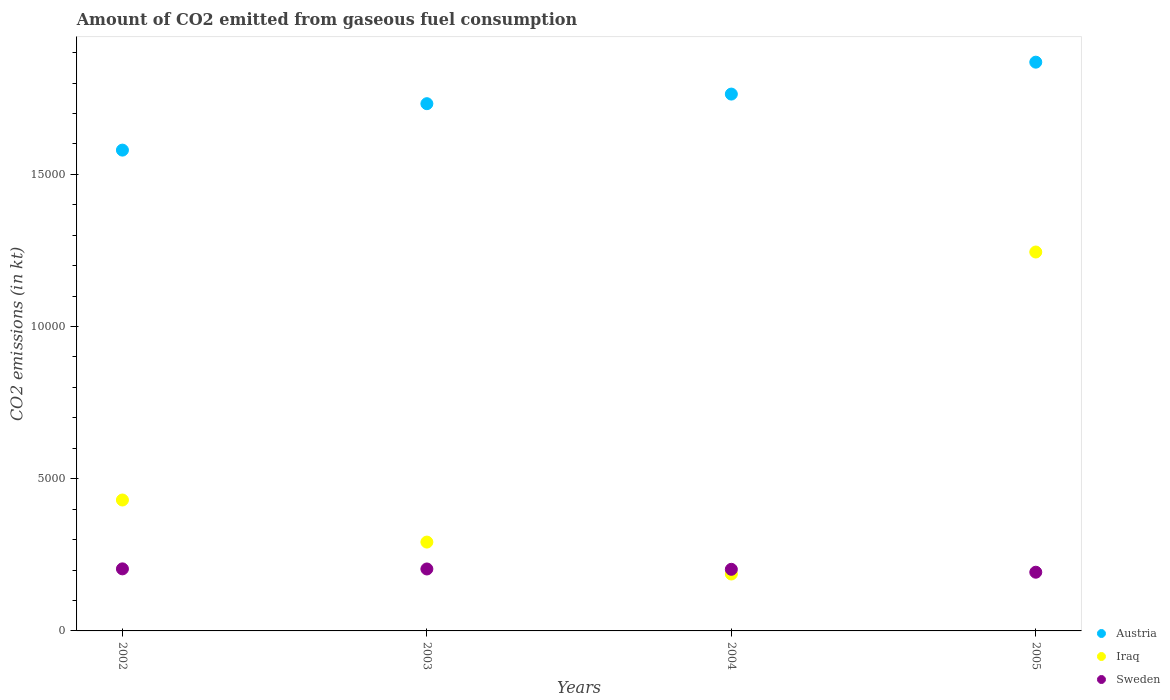How many different coloured dotlines are there?
Your response must be concise. 3. What is the amount of CO2 emitted in Iraq in 2004?
Keep it short and to the point. 1870.17. Across all years, what is the maximum amount of CO2 emitted in Sweden?
Keep it short and to the point. 2038.85. Across all years, what is the minimum amount of CO2 emitted in Austria?
Keep it short and to the point. 1.58e+04. What is the total amount of CO2 emitted in Austria in the graph?
Give a very brief answer. 6.94e+04. What is the difference between the amount of CO2 emitted in Austria in 2002 and that in 2004?
Give a very brief answer. -1840.83. What is the difference between the amount of CO2 emitted in Iraq in 2004 and the amount of CO2 emitted in Sweden in 2002?
Give a very brief answer. -168.68. What is the average amount of CO2 emitted in Iraq per year?
Your answer should be compact. 5384.99. In the year 2004, what is the difference between the amount of CO2 emitted in Sweden and amount of CO2 emitted in Austria?
Your answer should be compact. -1.56e+04. What is the ratio of the amount of CO2 emitted in Sweden in 2002 to that in 2005?
Offer a terse response. 1.06. Is the amount of CO2 emitted in Sweden in 2002 less than that in 2005?
Provide a succinct answer. No. Is the difference between the amount of CO2 emitted in Sweden in 2003 and 2005 greater than the difference between the amount of CO2 emitted in Austria in 2003 and 2005?
Your answer should be compact. Yes. What is the difference between the highest and the second highest amount of CO2 emitted in Austria?
Make the answer very short. 1048.76. What is the difference between the highest and the lowest amount of CO2 emitted in Austria?
Give a very brief answer. 2889.6. Is it the case that in every year, the sum of the amount of CO2 emitted in Sweden and amount of CO2 emitted in Austria  is greater than the amount of CO2 emitted in Iraq?
Keep it short and to the point. Yes. Does the amount of CO2 emitted in Sweden monotonically increase over the years?
Make the answer very short. No. Is the amount of CO2 emitted in Austria strictly greater than the amount of CO2 emitted in Iraq over the years?
Ensure brevity in your answer.  Yes. Is the amount of CO2 emitted in Iraq strictly less than the amount of CO2 emitted in Austria over the years?
Your response must be concise. Yes. How many dotlines are there?
Ensure brevity in your answer.  3. How many years are there in the graph?
Your answer should be compact. 4. What is the difference between two consecutive major ticks on the Y-axis?
Provide a succinct answer. 5000. Are the values on the major ticks of Y-axis written in scientific E-notation?
Your answer should be very brief. No. Does the graph contain any zero values?
Offer a very short reply. No. Does the graph contain grids?
Give a very brief answer. No. Where does the legend appear in the graph?
Ensure brevity in your answer.  Bottom right. How many legend labels are there?
Ensure brevity in your answer.  3. How are the legend labels stacked?
Make the answer very short. Vertical. What is the title of the graph?
Ensure brevity in your answer.  Amount of CO2 emitted from gaseous fuel consumption. What is the label or title of the Y-axis?
Ensure brevity in your answer.  CO2 emissions (in kt). What is the CO2 emissions (in kt) of Austria in 2002?
Your answer should be compact. 1.58e+04. What is the CO2 emissions (in kt) in Iraq in 2002?
Ensure brevity in your answer.  4301.39. What is the CO2 emissions (in kt) of Sweden in 2002?
Offer a terse response. 2038.85. What is the CO2 emissions (in kt) in Austria in 2003?
Offer a terse response. 1.73e+04. What is the CO2 emissions (in kt) of Iraq in 2003?
Offer a terse response. 2918.93. What is the CO2 emissions (in kt) in Sweden in 2003?
Your answer should be very brief. 2035.18. What is the CO2 emissions (in kt) of Austria in 2004?
Your answer should be compact. 1.76e+04. What is the CO2 emissions (in kt) of Iraq in 2004?
Give a very brief answer. 1870.17. What is the CO2 emissions (in kt) in Sweden in 2004?
Your response must be concise. 2024.18. What is the CO2 emissions (in kt) of Austria in 2005?
Provide a short and direct response. 1.87e+04. What is the CO2 emissions (in kt) in Iraq in 2005?
Give a very brief answer. 1.24e+04. What is the CO2 emissions (in kt) in Sweden in 2005?
Offer a terse response. 1928.84. Across all years, what is the maximum CO2 emissions (in kt) of Austria?
Keep it short and to the point. 1.87e+04. Across all years, what is the maximum CO2 emissions (in kt) of Iraq?
Your answer should be very brief. 1.24e+04. Across all years, what is the maximum CO2 emissions (in kt) of Sweden?
Provide a short and direct response. 2038.85. Across all years, what is the minimum CO2 emissions (in kt) of Austria?
Your response must be concise. 1.58e+04. Across all years, what is the minimum CO2 emissions (in kt) of Iraq?
Offer a terse response. 1870.17. Across all years, what is the minimum CO2 emissions (in kt) in Sweden?
Give a very brief answer. 1928.84. What is the total CO2 emissions (in kt) of Austria in the graph?
Ensure brevity in your answer.  6.94e+04. What is the total CO2 emissions (in kt) in Iraq in the graph?
Your answer should be very brief. 2.15e+04. What is the total CO2 emissions (in kt) of Sweden in the graph?
Give a very brief answer. 8027.06. What is the difference between the CO2 emissions (in kt) in Austria in 2002 and that in 2003?
Provide a short and direct response. -1525.47. What is the difference between the CO2 emissions (in kt) in Iraq in 2002 and that in 2003?
Make the answer very short. 1382.46. What is the difference between the CO2 emissions (in kt) of Sweden in 2002 and that in 2003?
Keep it short and to the point. 3.67. What is the difference between the CO2 emissions (in kt) in Austria in 2002 and that in 2004?
Offer a terse response. -1840.83. What is the difference between the CO2 emissions (in kt) of Iraq in 2002 and that in 2004?
Give a very brief answer. 2431.22. What is the difference between the CO2 emissions (in kt) of Sweden in 2002 and that in 2004?
Keep it short and to the point. 14.67. What is the difference between the CO2 emissions (in kt) in Austria in 2002 and that in 2005?
Provide a succinct answer. -2889.6. What is the difference between the CO2 emissions (in kt) of Iraq in 2002 and that in 2005?
Keep it short and to the point. -8148.07. What is the difference between the CO2 emissions (in kt) in Sweden in 2002 and that in 2005?
Your response must be concise. 110.01. What is the difference between the CO2 emissions (in kt) in Austria in 2003 and that in 2004?
Your answer should be very brief. -315.36. What is the difference between the CO2 emissions (in kt) of Iraq in 2003 and that in 2004?
Your answer should be very brief. 1048.76. What is the difference between the CO2 emissions (in kt) in Sweden in 2003 and that in 2004?
Keep it short and to the point. 11. What is the difference between the CO2 emissions (in kt) in Austria in 2003 and that in 2005?
Keep it short and to the point. -1364.12. What is the difference between the CO2 emissions (in kt) in Iraq in 2003 and that in 2005?
Offer a very short reply. -9530.53. What is the difference between the CO2 emissions (in kt) in Sweden in 2003 and that in 2005?
Provide a succinct answer. 106.34. What is the difference between the CO2 emissions (in kt) in Austria in 2004 and that in 2005?
Make the answer very short. -1048.76. What is the difference between the CO2 emissions (in kt) of Iraq in 2004 and that in 2005?
Your answer should be very brief. -1.06e+04. What is the difference between the CO2 emissions (in kt) of Sweden in 2004 and that in 2005?
Your answer should be very brief. 95.34. What is the difference between the CO2 emissions (in kt) of Austria in 2002 and the CO2 emissions (in kt) of Iraq in 2003?
Offer a very short reply. 1.29e+04. What is the difference between the CO2 emissions (in kt) in Austria in 2002 and the CO2 emissions (in kt) in Sweden in 2003?
Keep it short and to the point. 1.38e+04. What is the difference between the CO2 emissions (in kt) of Iraq in 2002 and the CO2 emissions (in kt) of Sweden in 2003?
Give a very brief answer. 2266.21. What is the difference between the CO2 emissions (in kt) in Austria in 2002 and the CO2 emissions (in kt) in Iraq in 2004?
Your answer should be very brief. 1.39e+04. What is the difference between the CO2 emissions (in kt) in Austria in 2002 and the CO2 emissions (in kt) in Sweden in 2004?
Give a very brief answer. 1.38e+04. What is the difference between the CO2 emissions (in kt) in Iraq in 2002 and the CO2 emissions (in kt) in Sweden in 2004?
Your response must be concise. 2277.21. What is the difference between the CO2 emissions (in kt) in Austria in 2002 and the CO2 emissions (in kt) in Iraq in 2005?
Offer a terse response. 3347.97. What is the difference between the CO2 emissions (in kt) of Austria in 2002 and the CO2 emissions (in kt) of Sweden in 2005?
Give a very brief answer. 1.39e+04. What is the difference between the CO2 emissions (in kt) of Iraq in 2002 and the CO2 emissions (in kt) of Sweden in 2005?
Provide a succinct answer. 2372.55. What is the difference between the CO2 emissions (in kt) in Austria in 2003 and the CO2 emissions (in kt) in Iraq in 2004?
Your answer should be very brief. 1.55e+04. What is the difference between the CO2 emissions (in kt) in Austria in 2003 and the CO2 emissions (in kt) in Sweden in 2004?
Your answer should be very brief. 1.53e+04. What is the difference between the CO2 emissions (in kt) of Iraq in 2003 and the CO2 emissions (in kt) of Sweden in 2004?
Provide a short and direct response. 894.75. What is the difference between the CO2 emissions (in kt) of Austria in 2003 and the CO2 emissions (in kt) of Iraq in 2005?
Your response must be concise. 4873.44. What is the difference between the CO2 emissions (in kt) of Austria in 2003 and the CO2 emissions (in kt) of Sweden in 2005?
Your answer should be compact. 1.54e+04. What is the difference between the CO2 emissions (in kt) of Iraq in 2003 and the CO2 emissions (in kt) of Sweden in 2005?
Your answer should be very brief. 990.09. What is the difference between the CO2 emissions (in kt) of Austria in 2004 and the CO2 emissions (in kt) of Iraq in 2005?
Your response must be concise. 5188.81. What is the difference between the CO2 emissions (in kt) in Austria in 2004 and the CO2 emissions (in kt) in Sweden in 2005?
Give a very brief answer. 1.57e+04. What is the difference between the CO2 emissions (in kt) of Iraq in 2004 and the CO2 emissions (in kt) of Sweden in 2005?
Your answer should be compact. -58.67. What is the average CO2 emissions (in kt) in Austria per year?
Keep it short and to the point. 1.74e+04. What is the average CO2 emissions (in kt) of Iraq per year?
Ensure brevity in your answer.  5384.99. What is the average CO2 emissions (in kt) of Sweden per year?
Give a very brief answer. 2006.77. In the year 2002, what is the difference between the CO2 emissions (in kt) of Austria and CO2 emissions (in kt) of Iraq?
Keep it short and to the point. 1.15e+04. In the year 2002, what is the difference between the CO2 emissions (in kt) in Austria and CO2 emissions (in kt) in Sweden?
Ensure brevity in your answer.  1.38e+04. In the year 2002, what is the difference between the CO2 emissions (in kt) of Iraq and CO2 emissions (in kt) of Sweden?
Provide a succinct answer. 2262.54. In the year 2003, what is the difference between the CO2 emissions (in kt) of Austria and CO2 emissions (in kt) of Iraq?
Your answer should be compact. 1.44e+04. In the year 2003, what is the difference between the CO2 emissions (in kt) in Austria and CO2 emissions (in kt) in Sweden?
Your answer should be very brief. 1.53e+04. In the year 2003, what is the difference between the CO2 emissions (in kt) of Iraq and CO2 emissions (in kt) of Sweden?
Provide a short and direct response. 883.75. In the year 2004, what is the difference between the CO2 emissions (in kt) of Austria and CO2 emissions (in kt) of Iraq?
Make the answer very short. 1.58e+04. In the year 2004, what is the difference between the CO2 emissions (in kt) in Austria and CO2 emissions (in kt) in Sweden?
Give a very brief answer. 1.56e+04. In the year 2004, what is the difference between the CO2 emissions (in kt) in Iraq and CO2 emissions (in kt) in Sweden?
Keep it short and to the point. -154.01. In the year 2005, what is the difference between the CO2 emissions (in kt) of Austria and CO2 emissions (in kt) of Iraq?
Keep it short and to the point. 6237.57. In the year 2005, what is the difference between the CO2 emissions (in kt) of Austria and CO2 emissions (in kt) of Sweden?
Keep it short and to the point. 1.68e+04. In the year 2005, what is the difference between the CO2 emissions (in kt) of Iraq and CO2 emissions (in kt) of Sweden?
Your answer should be compact. 1.05e+04. What is the ratio of the CO2 emissions (in kt) in Austria in 2002 to that in 2003?
Offer a very short reply. 0.91. What is the ratio of the CO2 emissions (in kt) of Iraq in 2002 to that in 2003?
Offer a very short reply. 1.47. What is the ratio of the CO2 emissions (in kt) of Austria in 2002 to that in 2004?
Offer a very short reply. 0.9. What is the ratio of the CO2 emissions (in kt) of Sweden in 2002 to that in 2004?
Provide a short and direct response. 1.01. What is the ratio of the CO2 emissions (in kt) of Austria in 2002 to that in 2005?
Keep it short and to the point. 0.85. What is the ratio of the CO2 emissions (in kt) of Iraq in 2002 to that in 2005?
Provide a short and direct response. 0.35. What is the ratio of the CO2 emissions (in kt) of Sweden in 2002 to that in 2005?
Keep it short and to the point. 1.06. What is the ratio of the CO2 emissions (in kt) of Austria in 2003 to that in 2004?
Your answer should be compact. 0.98. What is the ratio of the CO2 emissions (in kt) of Iraq in 2003 to that in 2004?
Your response must be concise. 1.56. What is the ratio of the CO2 emissions (in kt) in Sweden in 2003 to that in 2004?
Keep it short and to the point. 1.01. What is the ratio of the CO2 emissions (in kt) of Austria in 2003 to that in 2005?
Keep it short and to the point. 0.93. What is the ratio of the CO2 emissions (in kt) of Iraq in 2003 to that in 2005?
Ensure brevity in your answer.  0.23. What is the ratio of the CO2 emissions (in kt) of Sweden in 2003 to that in 2005?
Keep it short and to the point. 1.06. What is the ratio of the CO2 emissions (in kt) in Austria in 2004 to that in 2005?
Your answer should be compact. 0.94. What is the ratio of the CO2 emissions (in kt) of Iraq in 2004 to that in 2005?
Offer a very short reply. 0.15. What is the ratio of the CO2 emissions (in kt) of Sweden in 2004 to that in 2005?
Offer a terse response. 1.05. What is the difference between the highest and the second highest CO2 emissions (in kt) of Austria?
Give a very brief answer. 1048.76. What is the difference between the highest and the second highest CO2 emissions (in kt) of Iraq?
Offer a terse response. 8148.07. What is the difference between the highest and the second highest CO2 emissions (in kt) of Sweden?
Provide a short and direct response. 3.67. What is the difference between the highest and the lowest CO2 emissions (in kt) of Austria?
Your answer should be compact. 2889.6. What is the difference between the highest and the lowest CO2 emissions (in kt) in Iraq?
Offer a terse response. 1.06e+04. What is the difference between the highest and the lowest CO2 emissions (in kt) in Sweden?
Keep it short and to the point. 110.01. 